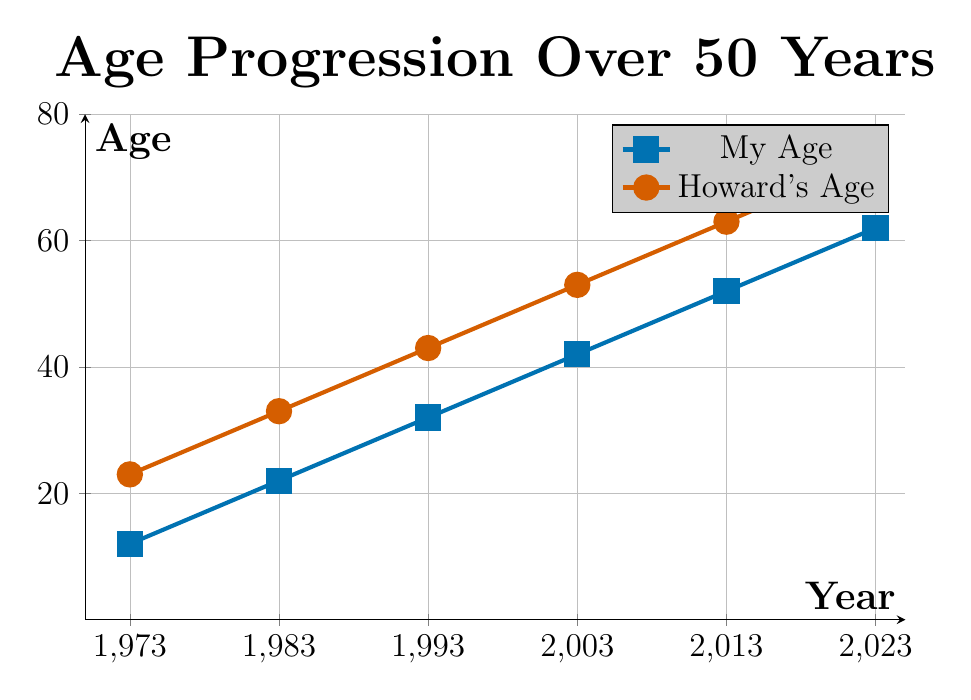what is the highest age Howard reached according to the plot? Howard's age is shown by the red line that ends at 2023. From the plot, the red dot at 2023 aligns with 73, indicating that Howard reached the age of 73 in that year.
Answer: 73 how old were you in 1993? The blue line represents your age. The point at 1993 on the blue line corresponds to 32, indicating you were 32 years old in that year.
Answer: 32 who was older in 2003, you or Howard? The blue line represents your age, which is 42 in 2003, and the red line represents Howard’s age, which is 53 in 2003. Since 53 is greater than 42, Howard was older.
Answer: Howard from 1983 to 2003, how many years did Howard's age increase? In 1983, Howard’s age was 33 and in 2003 it was 53. The difference between 53 and 33 is 20 years.
Answer: 20 years what color represents Howard's age in the plot? The plot shows two lines, and the red line represents Howard’s age information as indicated by the legend.
Answer: red what is the difference in age between you and Howard in 2013? In 2013, your age is 52 and Howard’s age is 63 as shown on the plot. The difference between 63 and 52 is 11 years.
Answer: 11 years if the current year is 2023, how many years will it be until Howard reaches 80? Howard is currently 73 years old in 2023 as shown on the plot. To find out how many more years until he reaches 80, subtract 73 from 80, which gives 7 years.
Answer: 7 years how much older was Howard than you in 1973? In 1973, your age is 12 and Howard’s age is 23. The difference between 23 and 12 is 11 years.
Answer: 11 years what is the average age of Howard every decade (1973, 1983, 1993, 2003, 2013, and 2023)? Howard's ages in each decade are 23, 33, 43, 53, 63, and 73 respectively. Sum these values: 23 + 33 + 43 + 53 + 63 + 73 = 288. The average is this sum divided by the number of data points, so 288 / 6 = 48.
Answer: 48 